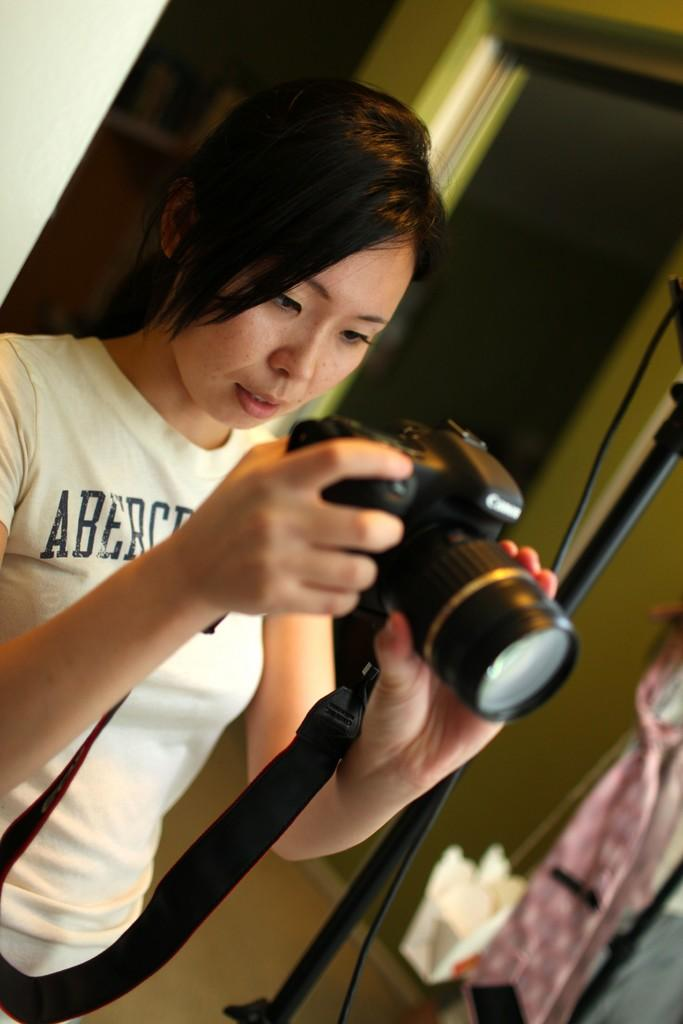Who is the main subject in the image? There is a woman in the image. What is the woman doing in the image? The woman is holding a camera in her hands and taking a picture. What can be seen in the background of the image? There is a wall, a stand, and clothes in the background of the image. What type of approval does the queen give to the woman in the image? There is no queen present in the image, so there is no approval to be given. What type of paper is the woman using to take the picture in the image? The woman is using a camera to take the picture, not paper. 